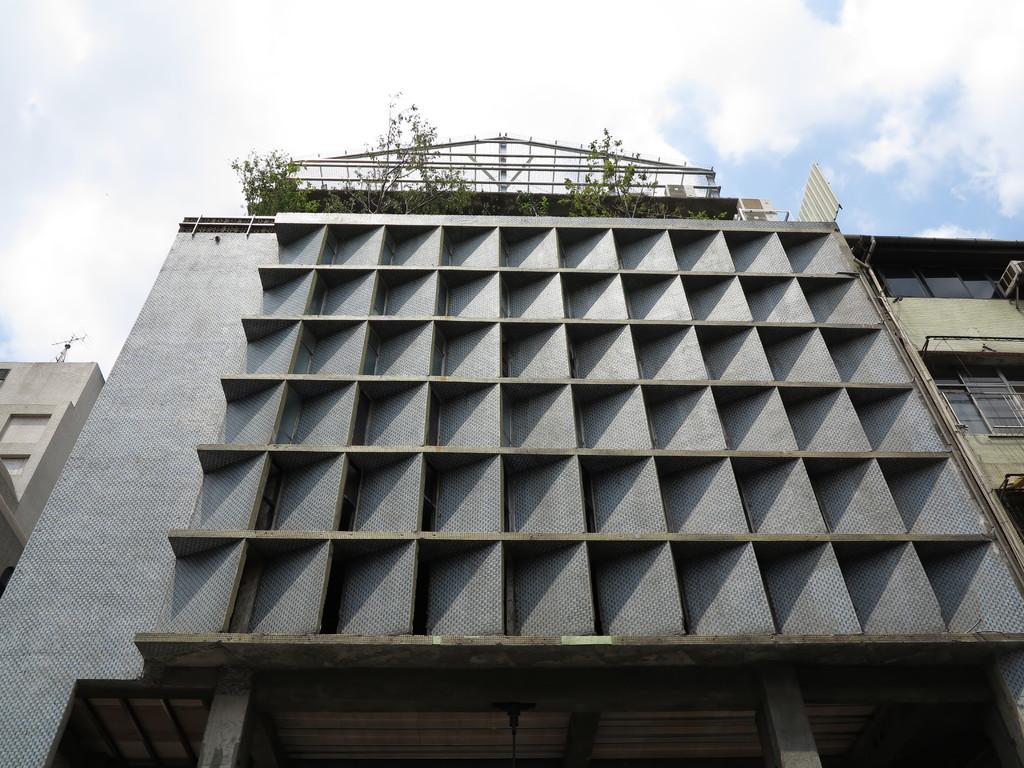Could you give a brief overview of what you see in this image? In this image, we can see a building. On the right side, we can see a building and a glass window, on the left side, we can see a building. At the top, we can see some plants and a sky which is a bit cloudy. 